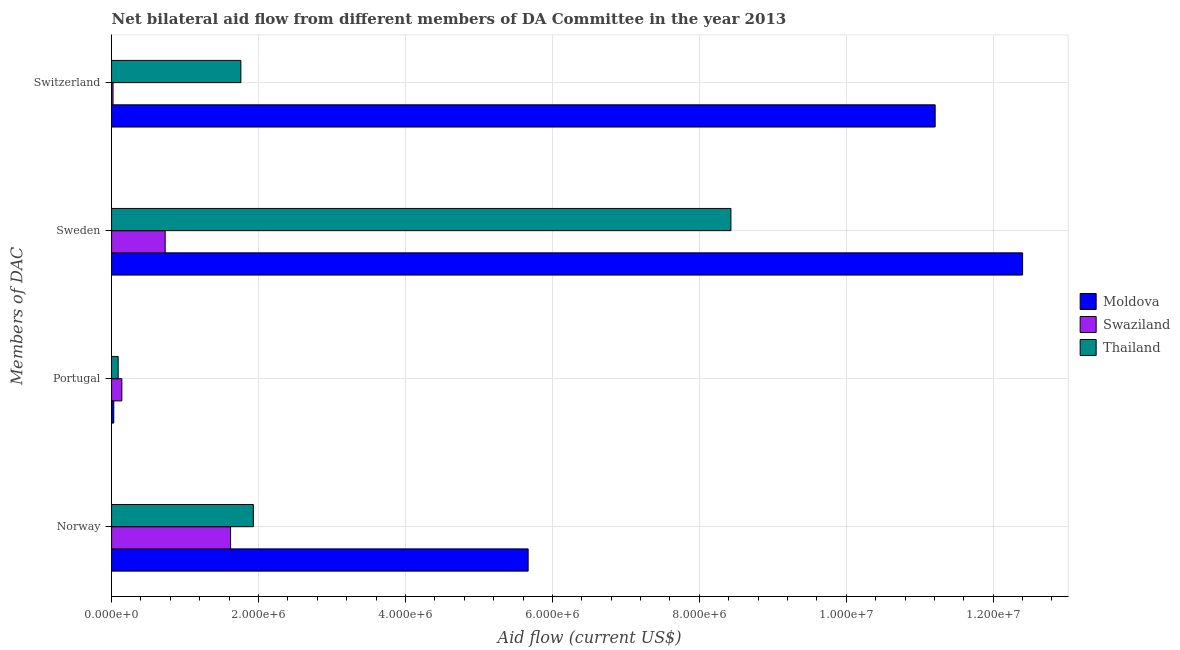How many groups of bars are there?
Your answer should be very brief. 4. Are the number of bars on each tick of the Y-axis equal?
Provide a succinct answer. Yes. How many bars are there on the 4th tick from the top?
Give a very brief answer. 3. What is the amount of aid given by norway in Swaziland?
Your answer should be compact. 1.62e+06. Across all countries, what is the maximum amount of aid given by norway?
Provide a short and direct response. 5.67e+06. Across all countries, what is the minimum amount of aid given by sweden?
Keep it short and to the point. 7.30e+05. In which country was the amount of aid given by portugal maximum?
Offer a terse response. Swaziland. In which country was the amount of aid given by sweden minimum?
Provide a succinct answer. Swaziland. What is the total amount of aid given by portugal in the graph?
Offer a terse response. 2.60e+05. What is the difference between the amount of aid given by portugal in Thailand and that in Moldova?
Your response must be concise. 6.00e+04. What is the difference between the amount of aid given by norway in Moldova and the amount of aid given by portugal in Swaziland?
Ensure brevity in your answer.  5.53e+06. What is the average amount of aid given by sweden per country?
Offer a very short reply. 7.19e+06. What is the difference between the amount of aid given by norway and amount of aid given by portugal in Moldova?
Provide a succinct answer. 5.64e+06. What is the ratio of the amount of aid given by switzerland in Swaziland to that in Thailand?
Give a very brief answer. 0.01. Is the amount of aid given by switzerland in Swaziland less than that in Thailand?
Make the answer very short. Yes. What is the difference between the highest and the second highest amount of aid given by switzerland?
Ensure brevity in your answer.  9.45e+06. What is the difference between the highest and the lowest amount of aid given by sweden?
Offer a terse response. 1.17e+07. In how many countries, is the amount of aid given by norway greater than the average amount of aid given by norway taken over all countries?
Your response must be concise. 1. Is it the case that in every country, the sum of the amount of aid given by sweden and amount of aid given by portugal is greater than the sum of amount of aid given by norway and amount of aid given by switzerland?
Your response must be concise. No. What does the 1st bar from the top in Sweden represents?
Ensure brevity in your answer.  Thailand. What does the 2nd bar from the bottom in Norway represents?
Your response must be concise. Swaziland. Is it the case that in every country, the sum of the amount of aid given by norway and amount of aid given by portugal is greater than the amount of aid given by sweden?
Your response must be concise. No. How many bars are there?
Offer a very short reply. 12. Are all the bars in the graph horizontal?
Make the answer very short. Yes. How many countries are there in the graph?
Your answer should be compact. 3. What is the difference between two consecutive major ticks on the X-axis?
Your response must be concise. 2.00e+06. Does the graph contain any zero values?
Offer a terse response. No. How many legend labels are there?
Your answer should be compact. 3. What is the title of the graph?
Provide a short and direct response. Net bilateral aid flow from different members of DA Committee in the year 2013. What is the label or title of the X-axis?
Your answer should be compact. Aid flow (current US$). What is the label or title of the Y-axis?
Offer a very short reply. Members of DAC. What is the Aid flow (current US$) of Moldova in Norway?
Give a very brief answer. 5.67e+06. What is the Aid flow (current US$) of Swaziland in Norway?
Give a very brief answer. 1.62e+06. What is the Aid flow (current US$) in Thailand in Norway?
Keep it short and to the point. 1.93e+06. What is the Aid flow (current US$) of Moldova in Portugal?
Offer a very short reply. 3.00e+04. What is the Aid flow (current US$) in Thailand in Portugal?
Ensure brevity in your answer.  9.00e+04. What is the Aid flow (current US$) of Moldova in Sweden?
Your answer should be compact. 1.24e+07. What is the Aid flow (current US$) of Swaziland in Sweden?
Your answer should be very brief. 7.30e+05. What is the Aid flow (current US$) in Thailand in Sweden?
Your response must be concise. 8.43e+06. What is the Aid flow (current US$) of Moldova in Switzerland?
Give a very brief answer. 1.12e+07. What is the Aid flow (current US$) of Swaziland in Switzerland?
Your response must be concise. 2.00e+04. What is the Aid flow (current US$) of Thailand in Switzerland?
Keep it short and to the point. 1.76e+06. Across all Members of DAC, what is the maximum Aid flow (current US$) in Moldova?
Provide a succinct answer. 1.24e+07. Across all Members of DAC, what is the maximum Aid flow (current US$) of Swaziland?
Your answer should be very brief. 1.62e+06. Across all Members of DAC, what is the maximum Aid flow (current US$) of Thailand?
Your answer should be compact. 8.43e+06. Across all Members of DAC, what is the minimum Aid flow (current US$) of Moldova?
Offer a very short reply. 3.00e+04. Across all Members of DAC, what is the minimum Aid flow (current US$) in Swaziland?
Offer a terse response. 2.00e+04. What is the total Aid flow (current US$) of Moldova in the graph?
Ensure brevity in your answer.  2.93e+07. What is the total Aid flow (current US$) in Swaziland in the graph?
Keep it short and to the point. 2.51e+06. What is the total Aid flow (current US$) of Thailand in the graph?
Your answer should be very brief. 1.22e+07. What is the difference between the Aid flow (current US$) of Moldova in Norway and that in Portugal?
Make the answer very short. 5.64e+06. What is the difference between the Aid flow (current US$) of Swaziland in Norway and that in Portugal?
Provide a succinct answer. 1.48e+06. What is the difference between the Aid flow (current US$) in Thailand in Norway and that in Portugal?
Your answer should be very brief. 1.84e+06. What is the difference between the Aid flow (current US$) in Moldova in Norway and that in Sweden?
Ensure brevity in your answer.  -6.73e+06. What is the difference between the Aid flow (current US$) of Swaziland in Norway and that in Sweden?
Offer a very short reply. 8.90e+05. What is the difference between the Aid flow (current US$) in Thailand in Norway and that in Sweden?
Give a very brief answer. -6.50e+06. What is the difference between the Aid flow (current US$) in Moldova in Norway and that in Switzerland?
Make the answer very short. -5.54e+06. What is the difference between the Aid flow (current US$) of Swaziland in Norway and that in Switzerland?
Give a very brief answer. 1.60e+06. What is the difference between the Aid flow (current US$) in Thailand in Norway and that in Switzerland?
Ensure brevity in your answer.  1.70e+05. What is the difference between the Aid flow (current US$) in Moldova in Portugal and that in Sweden?
Offer a terse response. -1.24e+07. What is the difference between the Aid flow (current US$) in Swaziland in Portugal and that in Sweden?
Keep it short and to the point. -5.90e+05. What is the difference between the Aid flow (current US$) in Thailand in Portugal and that in Sweden?
Offer a terse response. -8.34e+06. What is the difference between the Aid flow (current US$) in Moldova in Portugal and that in Switzerland?
Offer a terse response. -1.12e+07. What is the difference between the Aid flow (current US$) of Thailand in Portugal and that in Switzerland?
Your answer should be compact. -1.67e+06. What is the difference between the Aid flow (current US$) of Moldova in Sweden and that in Switzerland?
Offer a very short reply. 1.19e+06. What is the difference between the Aid flow (current US$) of Swaziland in Sweden and that in Switzerland?
Provide a short and direct response. 7.10e+05. What is the difference between the Aid flow (current US$) of Thailand in Sweden and that in Switzerland?
Provide a short and direct response. 6.67e+06. What is the difference between the Aid flow (current US$) of Moldova in Norway and the Aid flow (current US$) of Swaziland in Portugal?
Offer a terse response. 5.53e+06. What is the difference between the Aid flow (current US$) in Moldova in Norway and the Aid flow (current US$) in Thailand in Portugal?
Your answer should be very brief. 5.58e+06. What is the difference between the Aid flow (current US$) in Swaziland in Norway and the Aid flow (current US$) in Thailand in Portugal?
Provide a succinct answer. 1.53e+06. What is the difference between the Aid flow (current US$) of Moldova in Norway and the Aid flow (current US$) of Swaziland in Sweden?
Offer a very short reply. 4.94e+06. What is the difference between the Aid flow (current US$) in Moldova in Norway and the Aid flow (current US$) in Thailand in Sweden?
Offer a very short reply. -2.76e+06. What is the difference between the Aid flow (current US$) in Swaziland in Norway and the Aid flow (current US$) in Thailand in Sweden?
Ensure brevity in your answer.  -6.81e+06. What is the difference between the Aid flow (current US$) in Moldova in Norway and the Aid flow (current US$) in Swaziland in Switzerland?
Your response must be concise. 5.65e+06. What is the difference between the Aid flow (current US$) of Moldova in Norway and the Aid flow (current US$) of Thailand in Switzerland?
Ensure brevity in your answer.  3.91e+06. What is the difference between the Aid flow (current US$) in Moldova in Portugal and the Aid flow (current US$) in Swaziland in Sweden?
Offer a terse response. -7.00e+05. What is the difference between the Aid flow (current US$) of Moldova in Portugal and the Aid flow (current US$) of Thailand in Sweden?
Your response must be concise. -8.40e+06. What is the difference between the Aid flow (current US$) of Swaziland in Portugal and the Aid flow (current US$) of Thailand in Sweden?
Ensure brevity in your answer.  -8.29e+06. What is the difference between the Aid flow (current US$) of Moldova in Portugal and the Aid flow (current US$) of Thailand in Switzerland?
Provide a succinct answer. -1.73e+06. What is the difference between the Aid flow (current US$) of Swaziland in Portugal and the Aid flow (current US$) of Thailand in Switzerland?
Your response must be concise. -1.62e+06. What is the difference between the Aid flow (current US$) of Moldova in Sweden and the Aid flow (current US$) of Swaziland in Switzerland?
Make the answer very short. 1.24e+07. What is the difference between the Aid flow (current US$) in Moldova in Sweden and the Aid flow (current US$) in Thailand in Switzerland?
Provide a succinct answer. 1.06e+07. What is the difference between the Aid flow (current US$) of Swaziland in Sweden and the Aid flow (current US$) of Thailand in Switzerland?
Your response must be concise. -1.03e+06. What is the average Aid flow (current US$) in Moldova per Members of DAC?
Provide a short and direct response. 7.33e+06. What is the average Aid flow (current US$) of Swaziland per Members of DAC?
Offer a terse response. 6.28e+05. What is the average Aid flow (current US$) in Thailand per Members of DAC?
Offer a terse response. 3.05e+06. What is the difference between the Aid flow (current US$) in Moldova and Aid flow (current US$) in Swaziland in Norway?
Keep it short and to the point. 4.05e+06. What is the difference between the Aid flow (current US$) of Moldova and Aid flow (current US$) of Thailand in Norway?
Ensure brevity in your answer.  3.74e+06. What is the difference between the Aid flow (current US$) of Swaziland and Aid flow (current US$) of Thailand in Norway?
Ensure brevity in your answer.  -3.10e+05. What is the difference between the Aid flow (current US$) in Moldova and Aid flow (current US$) in Swaziland in Portugal?
Give a very brief answer. -1.10e+05. What is the difference between the Aid flow (current US$) of Moldova and Aid flow (current US$) of Thailand in Portugal?
Provide a short and direct response. -6.00e+04. What is the difference between the Aid flow (current US$) in Moldova and Aid flow (current US$) in Swaziland in Sweden?
Ensure brevity in your answer.  1.17e+07. What is the difference between the Aid flow (current US$) of Moldova and Aid flow (current US$) of Thailand in Sweden?
Your answer should be very brief. 3.97e+06. What is the difference between the Aid flow (current US$) in Swaziland and Aid flow (current US$) in Thailand in Sweden?
Offer a very short reply. -7.70e+06. What is the difference between the Aid flow (current US$) in Moldova and Aid flow (current US$) in Swaziland in Switzerland?
Ensure brevity in your answer.  1.12e+07. What is the difference between the Aid flow (current US$) in Moldova and Aid flow (current US$) in Thailand in Switzerland?
Your response must be concise. 9.45e+06. What is the difference between the Aid flow (current US$) of Swaziland and Aid flow (current US$) of Thailand in Switzerland?
Provide a succinct answer. -1.74e+06. What is the ratio of the Aid flow (current US$) of Moldova in Norway to that in Portugal?
Provide a short and direct response. 189. What is the ratio of the Aid flow (current US$) in Swaziland in Norway to that in Portugal?
Offer a terse response. 11.57. What is the ratio of the Aid flow (current US$) of Thailand in Norway to that in Portugal?
Keep it short and to the point. 21.44. What is the ratio of the Aid flow (current US$) of Moldova in Norway to that in Sweden?
Offer a very short reply. 0.46. What is the ratio of the Aid flow (current US$) of Swaziland in Norway to that in Sweden?
Offer a terse response. 2.22. What is the ratio of the Aid flow (current US$) in Thailand in Norway to that in Sweden?
Your response must be concise. 0.23. What is the ratio of the Aid flow (current US$) in Moldova in Norway to that in Switzerland?
Give a very brief answer. 0.51. What is the ratio of the Aid flow (current US$) of Swaziland in Norway to that in Switzerland?
Ensure brevity in your answer.  81. What is the ratio of the Aid flow (current US$) in Thailand in Norway to that in Switzerland?
Make the answer very short. 1.1. What is the ratio of the Aid flow (current US$) of Moldova in Portugal to that in Sweden?
Your answer should be compact. 0. What is the ratio of the Aid flow (current US$) in Swaziland in Portugal to that in Sweden?
Provide a short and direct response. 0.19. What is the ratio of the Aid flow (current US$) in Thailand in Portugal to that in Sweden?
Your answer should be compact. 0.01. What is the ratio of the Aid flow (current US$) of Moldova in Portugal to that in Switzerland?
Your response must be concise. 0. What is the ratio of the Aid flow (current US$) in Swaziland in Portugal to that in Switzerland?
Offer a very short reply. 7. What is the ratio of the Aid flow (current US$) of Thailand in Portugal to that in Switzerland?
Provide a succinct answer. 0.05. What is the ratio of the Aid flow (current US$) in Moldova in Sweden to that in Switzerland?
Provide a short and direct response. 1.11. What is the ratio of the Aid flow (current US$) of Swaziland in Sweden to that in Switzerland?
Give a very brief answer. 36.5. What is the ratio of the Aid flow (current US$) of Thailand in Sweden to that in Switzerland?
Offer a very short reply. 4.79. What is the difference between the highest and the second highest Aid flow (current US$) of Moldova?
Provide a short and direct response. 1.19e+06. What is the difference between the highest and the second highest Aid flow (current US$) of Swaziland?
Make the answer very short. 8.90e+05. What is the difference between the highest and the second highest Aid flow (current US$) in Thailand?
Ensure brevity in your answer.  6.50e+06. What is the difference between the highest and the lowest Aid flow (current US$) in Moldova?
Offer a very short reply. 1.24e+07. What is the difference between the highest and the lowest Aid flow (current US$) of Swaziland?
Give a very brief answer. 1.60e+06. What is the difference between the highest and the lowest Aid flow (current US$) of Thailand?
Make the answer very short. 8.34e+06. 